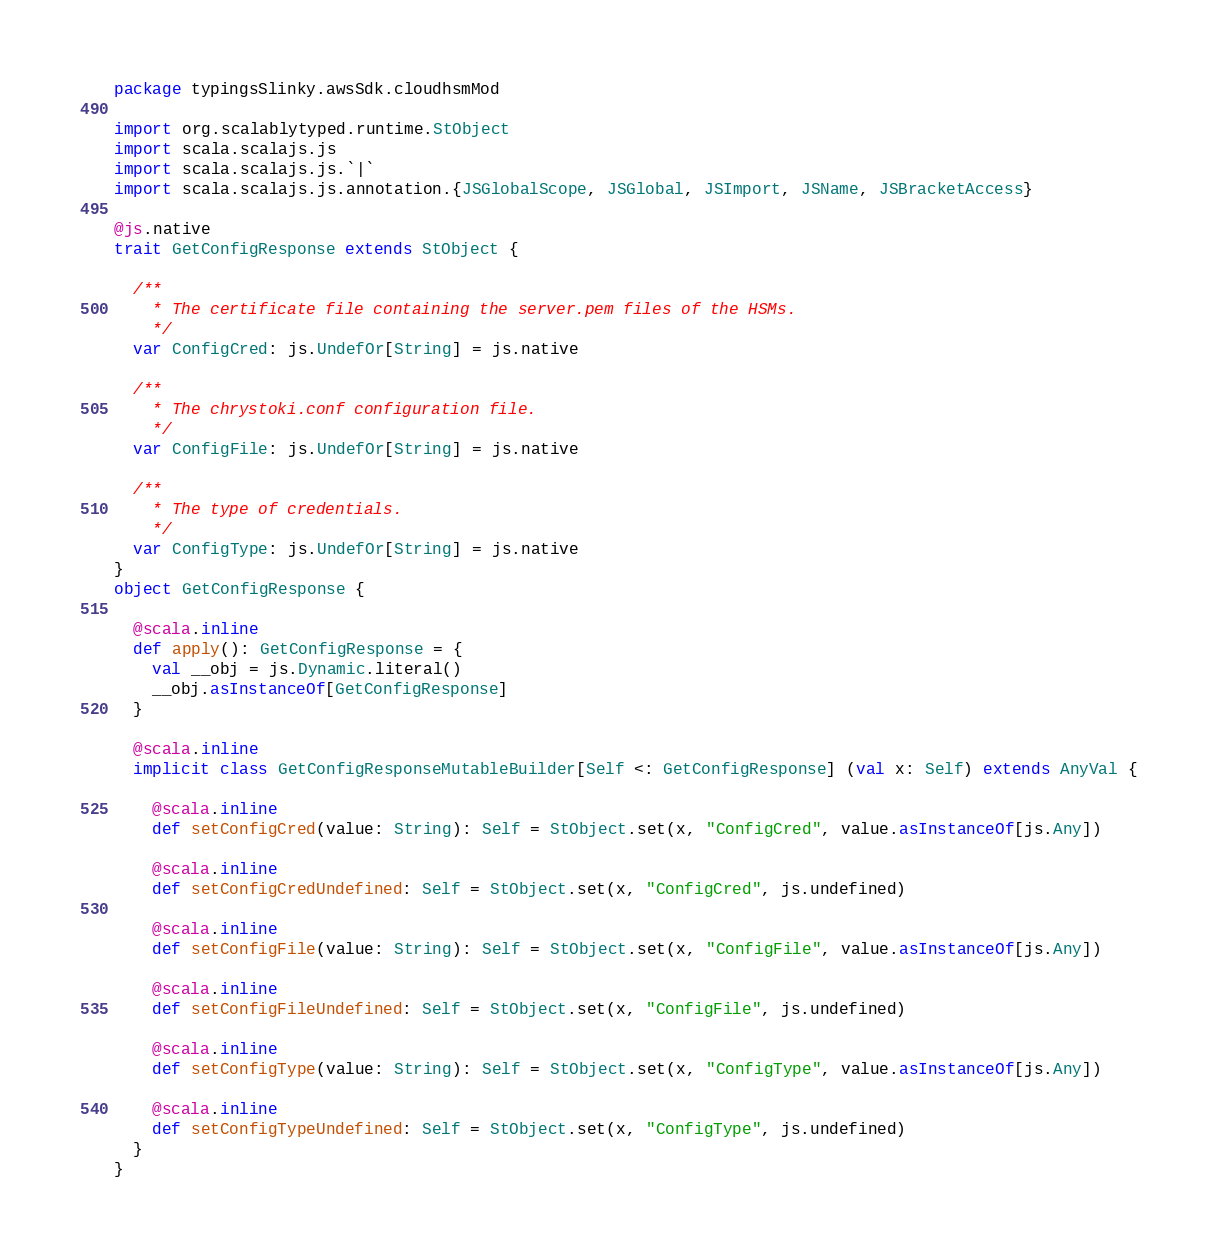Convert code to text. <code><loc_0><loc_0><loc_500><loc_500><_Scala_>package typingsSlinky.awsSdk.cloudhsmMod

import org.scalablytyped.runtime.StObject
import scala.scalajs.js
import scala.scalajs.js.`|`
import scala.scalajs.js.annotation.{JSGlobalScope, JSGlobal, JSImport, JSName, JSBracketAccess}

@js.native
trait GetConfigResponse extends StObject {
  
  /**
    * The certificate file containing the server.pem files of the HSMs.
    */
  var ConfigCred: js.UndefOr[String] = js.native
  
  /**
    * The chrystoki.conf configuration file.
    */
  var ConfigFile: js.UndefOr[String] = js.native
  
  /**
    * The type of credentials.
    */
  var ConfigType: js.UndefOr[String] = js.native
}
object GetConfigResponse {
  
  @scala.inline
  def apply(): GetConfigResponse = {
    val __obj = js.Dynamic.literal()
    __obj.asInstanceOf[GetConfigResponse]
  }
  
  @scala.inline
  implicit class GetConfigResponseMutableBuilder[Self <: GetConfigResponse] (val x: Self) extends AnyVal {
    
    @scala.inline
    def setConfigCred(value: String): Self = StObject.set(x, "ConfigCred", value.asInstanceOf[js.Any])
    
    @scala.inline
    def setConfigCredUndefined: Self = StObject.set(x, "ConfigCred", js.undefined)
    
    @scala.inline
    def setConfigFile(value: String): Self = StObject.set(x, "ConfigFile", value.asInstanceOf[js.Any])
    
    @scala.inline
    def setConfigFileUndefined: Self = StObject.set(x, "ConfigFile", js.undefined)
    
    @scala.inline
    def setConfigType(value: String): Self = StObject.set(x, "ConfigType", value.asInstanceOf[js.Any])
    
    @scala.inline
    def setConfigTypeUndefined: Self = StObject.set(x, "ConfigType", js.undefined)
  }
}
</code> 